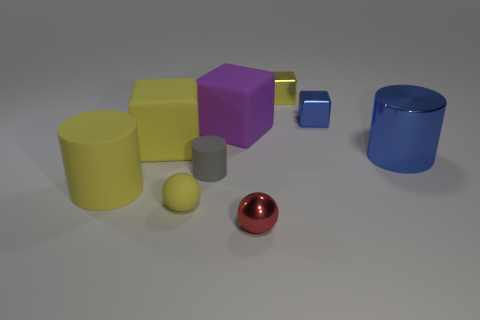Are there fewer small yellow cubes than brown metal things?
Your answer should be compact. No. There is a matte object in front of the big cylinder that is in front of the big blue cylinder; how many tiny metallic spheres are in front of it?
Offer a very short reply. 1. What size is the shiny block that is in front of the small yellow metallic block?
Offer a very short reply. Small. Do the big object on the right side of the small red thing and the red thing have the same shape?
Offer a very short reply. No. There is another large thing that is the same shape as the big purple matte thing; what is it made of?
Give a very brief answer. Rubber. Is there anything else that is the same size as the purple cube?
Keep it short and to the point. Yes. Is there a small yellow sphere?
Your response must be concise. Yes. There is a big cylinder left of the yellow block to the right of the small metal object that is in front of the large yellow matte cylinder; what is its material?
Offer a very short reply. Rubber. Is the shape of the large blue object the same as the tiny shiny thing in front of the tiny yellow matte ball?
Provide a succinct answer. No. How many gray rubber things have the same shape as the tiny blue metallic thing?
Your answer should be very brief. 0. 